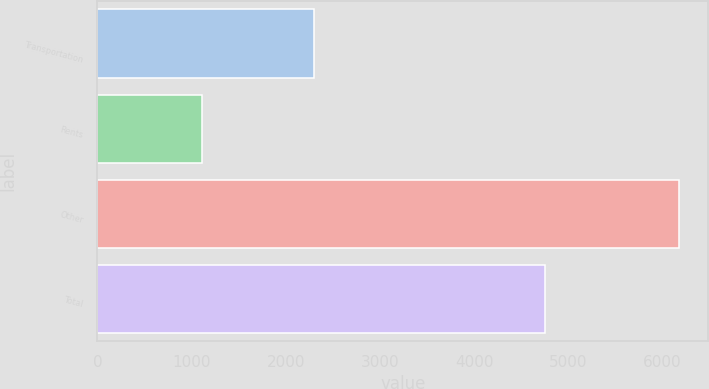Convert chart to OTSL. <chart><loc_0><loc_0><loc_500><loc_500><bar_chart><fcel>Transportation<fcel>Rents<fcel>Other<fcel>Total<nl><fcel>2297<fcel>1113<fcel>6178<fcel>4755<nl></chart> 